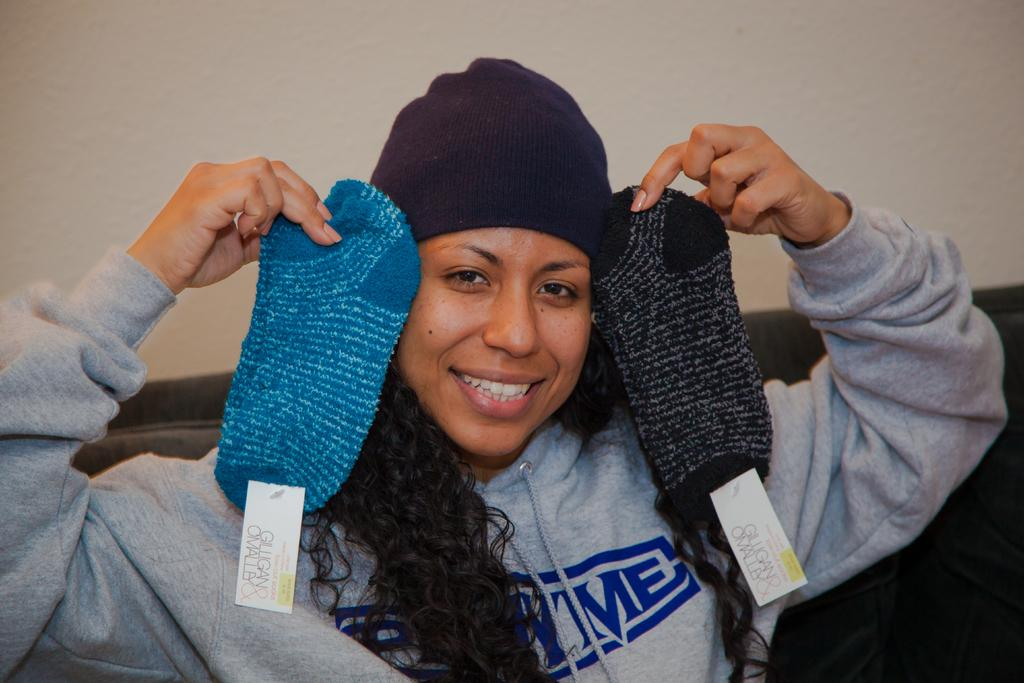Who is the main subject in the foreground of the image? There is a woman in the foreground of the image. What is the woman holding in her hands? The woman is holding two socks. What type of furniture can be seen in the image? There is a couch in the image. What is visible in the background of the image? There is a wall in the background of the image. What type of paint is the woman using on the cattle in the image? There is no paint or cattle present in the image; it features a woman holding two socks and a couch in the background. 